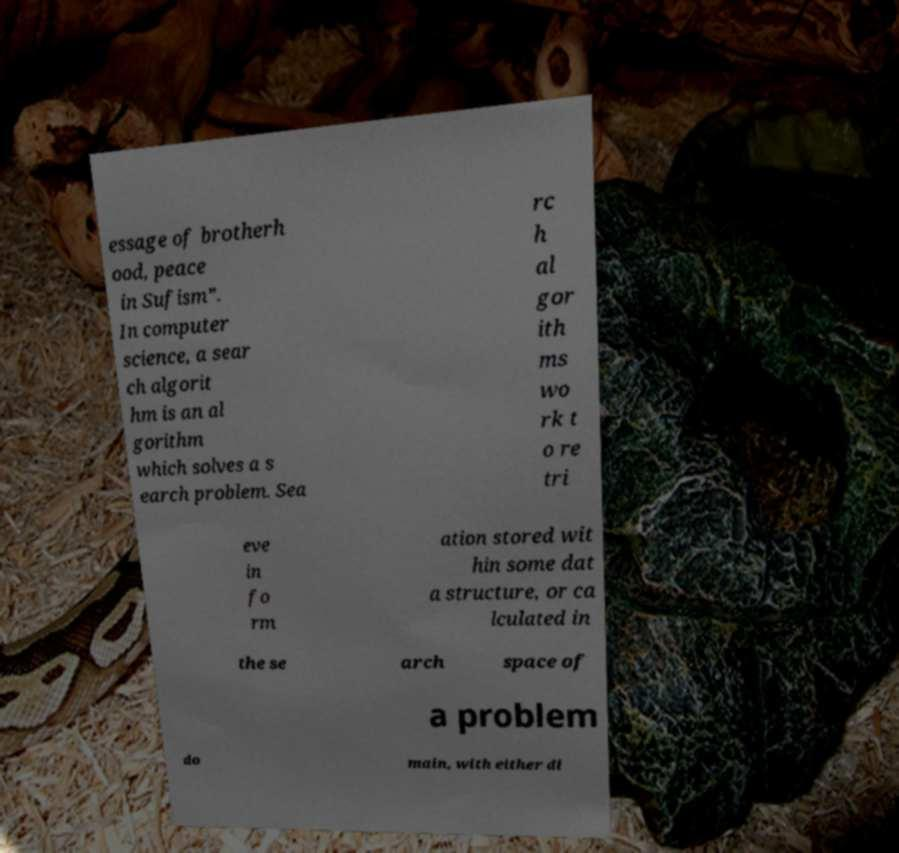I need the written content from this picture converted into text. Can you do that? essage of brotherh ood, peace in Sufism”. In computer science, a sear ch algorit hm is an al gorithm which solves a s earch problem. Sea rc h al gor ith ms wo rk t o re tri eve in fo rm ation stored wit hin some dat a structure, or ca lculated in the se arch space of a problem do main, with either di 